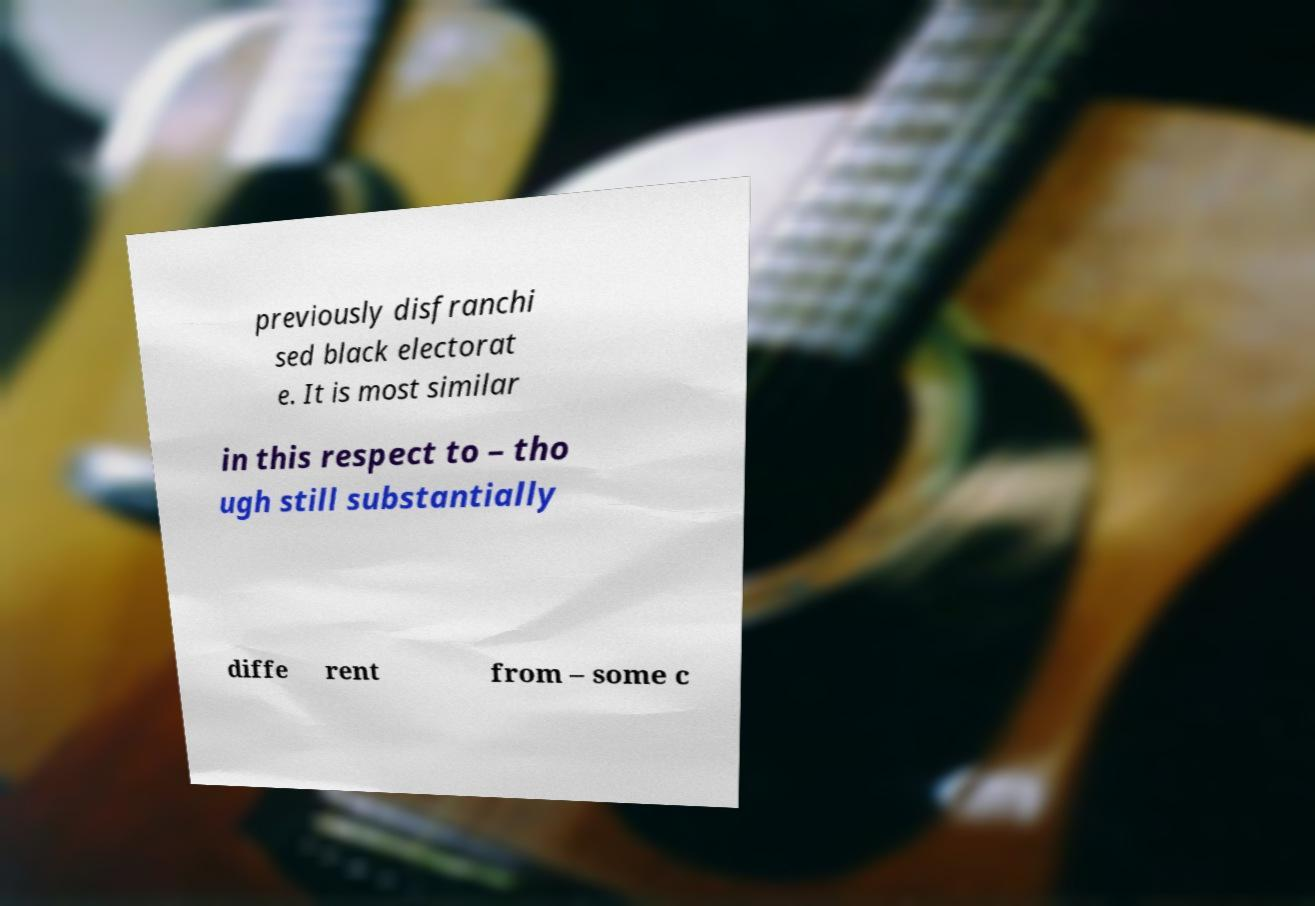Please read and relay the text visible in this image. What does it say? previously disfranchi sed black electorat e. It is most similar in this respect to – tho ugh still substantially diffe rent from – some c 